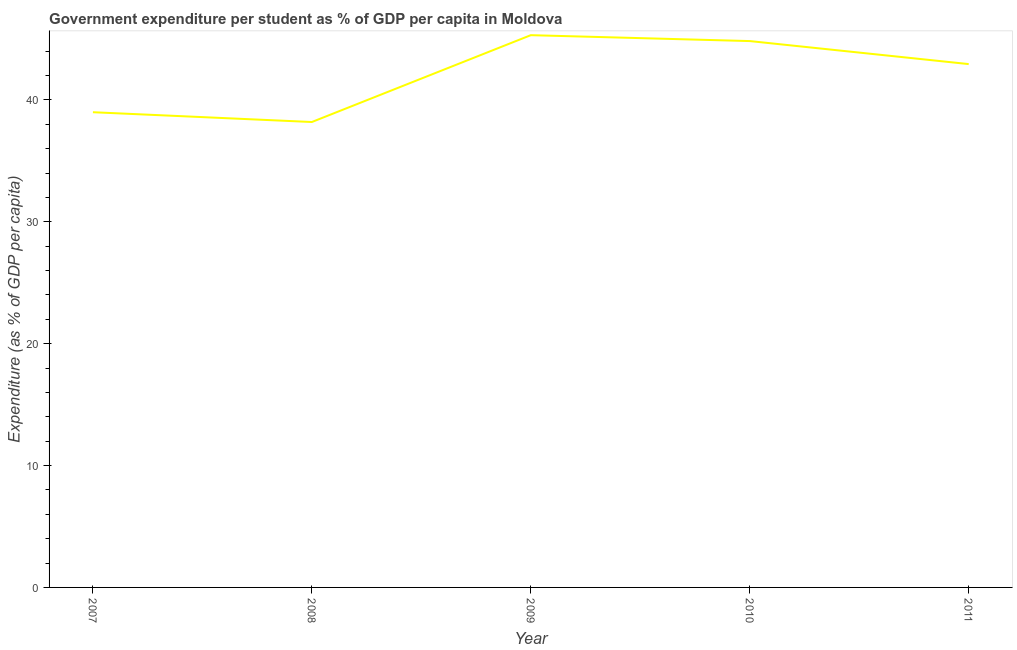What is the government expenditure per student in 2010?
Provide a short and direct response. 44.82. Across all years, what is the maximum government expenditure per student?
Provide a succinct answer. 45.31. Across all years, what is the minimum government expenditure per student?
Provide a succinct answer. 38.18. In which year was the government expenditure per student maximum?
Your answer should be very brief. 2009. In which year was the government expenditure per student minimum?
Offer a very short reply. 2008. What is the sum of the government expenditure per student?
Provide a succinct answer. 210.24. What is the difference between the government expenditure per student in 2010 and 2011?
Make the answer very short. 1.89. What is the average government expenditure per student per year?
Offer a very short reply. 42.05. What is the median government expenditure per student?
Make the answer very short. 42.94. What is the ratio of the government expenditure per student in 2009 to that in 2011?
Make the answer very short. 1.06. What is the difference between the highest and the second highest government expenditure per student?
Your answer should be compact. 0.48. What is the difference between the highest and the lowest government expenditure per student?
Give a very brief answer. 7.12. How many lines are there?
Make the answer very short. 1. What is the difference between two consecutive major ticks on the Y-axis?
Make the answer very short. 10. Are the values on the major ticks of Y-axis written in scientific E-notation?
Your answer should be very brief. No. Does the graph contain any zero values?
Provide a short and direct response. No. Does the graph contain grids?
Your response must be concise. No. What is the title of the graph?
Offer a very short reply. Government expenditure per student as % of GDP per capita in Moldova. What is the label or title of the Y-axis?
Keep it short and to the point. Expenditure (as % of GDP per capita). What is the Expenditure (as % of GDP per capita) of 2007?
Make the answer very short. 38.99. What is the Expenditure (as % of GDP per capita) of 2008?
Offer a terse response. 38.18. What is the Expenditure (as % of GDP per capita) of 2009?
Offer a terse response. 45.31. What is the Expenditure (as % of GDP per capita) of 2010?
Give a very brief answer. 44.82. What is the Expenditure (as % of GDP per capita) of 2011?
Provide a short and direct response. 42.94. What is the difference between the Expenditure (as % of GDP per capita) in 2007 and 2008?
Give a very brief answer. 0.8. What is the difference between the Expenditure (as % of GDP per capita) in 2007 and 2009?
Provide a succinct answer. -6.32. What is the difference between the Expenditure (as % of GDP per capita) in 2007 and 2010?
Your answer should be compact. -5.84. What is the difference between the Expenditure (as % of GDP per capita) in 2007 and 2011?
Ensure brevity in your answer.  -3.95. What is the difference between the Expenditure (as % of GDP per capita) in 2008 and 2009?
Make the answer very short. -7.12. What is the difference between the Expenditure (as % of GDP per capita) in 2008 and 2010?
Provide a succinct answer. -6.64. What is the difference between the Expenditure (as % of GDP per capita) in 2008 and 2011?
Keep it short and to the point. -4.75. What is the difference between the Expenditure (as % of GDP per capita) in 2009 and 2010?
Offer a terse response. 0.48. What is the difference between the Expenditure (as % of GDP per capita) in 2009 and 2011?
Make the answer very short. 2.37. What is the difference between the Expenditure (as % of GDP per capita) in 2010 and 2011?
Give a very brief answer. 1.89. What is the ratio of the Expenditure (as % of GDP per capita) in 2007 to that in 2008?
Give a very brief answer. 1.02. What is the ratio of the Expenditure (as % of GDP per capita) in 2007 to that in 2009?
Ensure brevity in your answer.  0.86. What is the ratio of the Expenditure (as % of GDP per capita) in 2007 to that in 2010?
Make the answer very short. 0.87. What is the ratio of the Expenditure (as % of GDP per capita) in 2007 to that in 2011?
Your answer should be compact. 0.91. What is the ratio of the Expenditure (as % of GDP per capita) in 2008 to that in 2009?
Offer a very short reply. 0.84. What is the ratio of the Expenditure (as % of GDP per capita) in 2008 to that in 2010?
Keep it short and to the point. 0.85. What is the ratio of the Expenditure (as % of GDP per capita) in 2008 to that in 2011?
Offer a terse response. 0.89. What is the ratio of the Expenditure (as % of GDP per capita) in 2009 to that in 2011?
Make the answer very short. 1.05. What is the ratio of the Expenditure (as % of GDP per capita) in 2010 to that in 2011?
Offer a terse response. 1.04. 